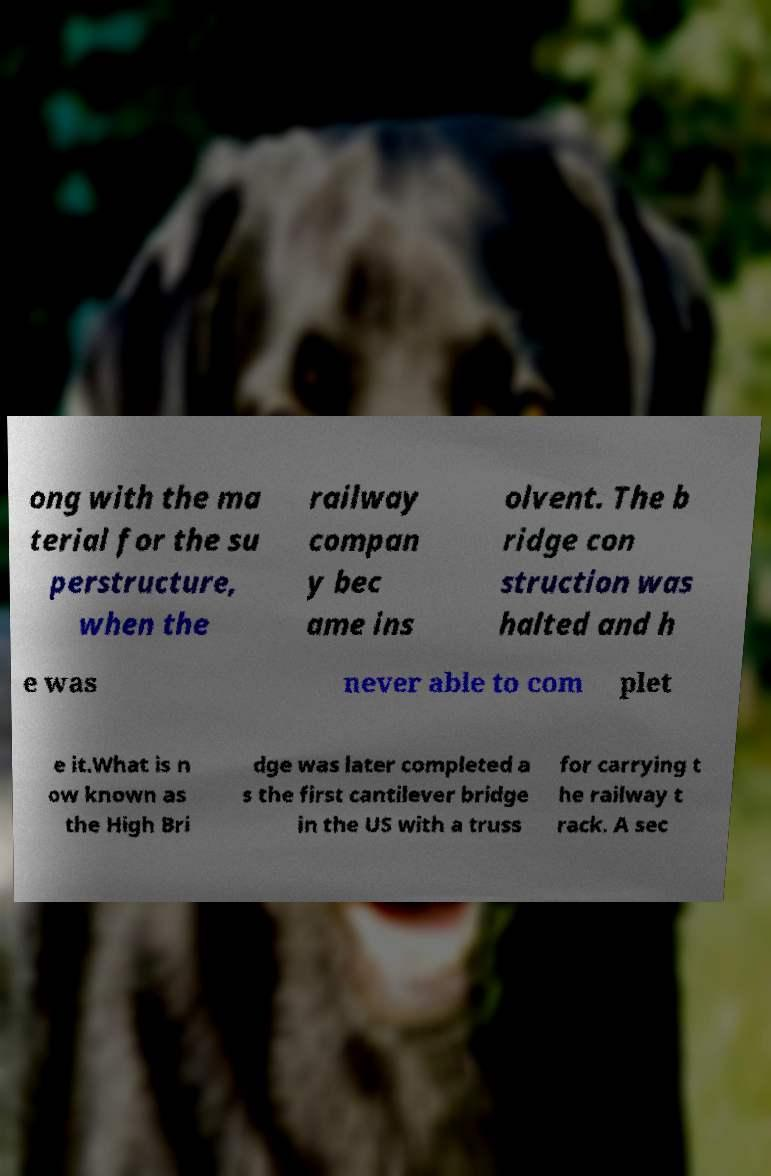For documentation purposes, I need the text within this image transcribed. Could you provide that? ong with the ma terial for the su perstructure, when the railway compan y bec ame ins olvent. The b ridge con struction was halted and h e was never able to com plet e it.What is n ow known as the High Bri dge was later completed a s the first cantilever bridge in the US with a truss for carrying t he railway t rack. A sec 